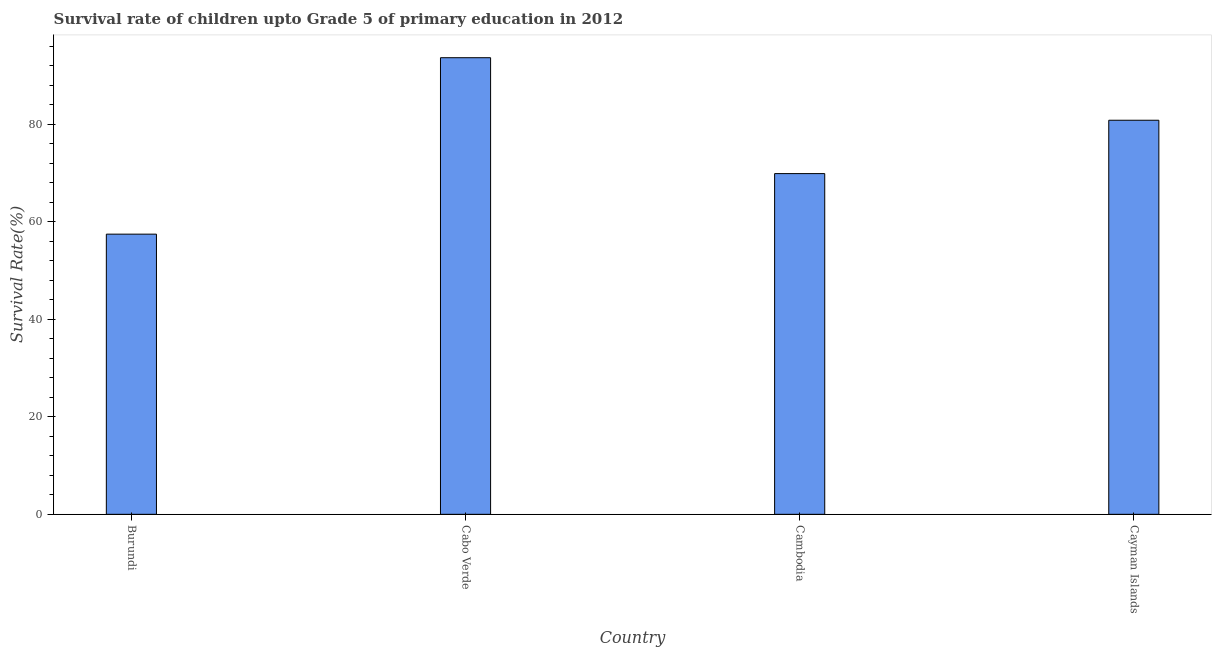Does the graph contain any zero values?
Offer a terse response. No. Does the graph contain grids?
Your response must be concise. No. What is the title of the graph?
Offer a very short reply. Survival rate of children upto Grade 5 of primary education in 2012 . What is the label or title of the X-axis?
Make the answer very short. Country. What is the label or title of the Y-axis?
Offer a terse response. Survival Rate(%). What is the survival rate in Burundi?
Your response must be concise. 57.44. Across all countries, what is the maximum survival rate?
Keep it short and to the point. 93.62. Across all countries, what is the minimum survival rate?
Offer a terse response. 57.44. In which country was the survival rate maximum?
Provide a succinct answer. Cabo Verde. In which country was the survival rate minimum?
Your answer should be very brief. Burundi. What is the sum of the survival rate?
Offer a terse response. 301.72. What is the difference between the survival rate in Burundi and Cabo Verde?
Make the answer very short. -36.17. What is the average survival rate per country?
Your answer should be very brief. 75.43. What is the median survival rate?
Your response must be concise. 75.33. In how many countries, is the survival rate greater than 4 %?
Your answer should be compact. 4. What is the ratio of the survival rate in Cabo Verde to that in Cambodia?
Provide a succinct answer. 1.34. Is the survival rate in Burundi less than that in Cabo Verde?
Give a very brief answer. Yes. What is the difference between the highest and the second highest survival rate?
Offer a terse response. 12.82. Is the sum of the survival rate in Cabo Verde and Cayman Islands greater than the maximum survival rate across all countries?
Your answer should be very brief. Yes. What is the difference between the highest and the lowest survival rate?
Your answer should be very brief. 36.18. How many bars are there?
Provide a succinct answer. 4. How many countries are there in the graph?
Provide a short and direct response. 4. What is the difference between two consecutive major ticks on the Y-axis?
Your answer should be very brief. 20. What is the Survival Rate(%) in Burundi?
Offer a terse response. 57.44. What is the Survival Rate(%) of Cabo Verde?
Your answer should be compact. 93.62. What is the Survival Rate(%) in Cambodia?
Provide a succinct answer. 69.86. What is the Survival Rate(%) in Cayman Islands?
Your answer should be very brief. 80.8. What is the difference between the Survival Rate(%) in Burundi and Cabo Verde?
Provide a short and direct response. -36.18. What is the difference between the Survival Rate(%) in Burundi and Cambodia?
Provide a short and direct response. -12.41. What is the difference between the Survival Rate(%) in Burundi and Cayman Islands?
Provide a succinct answer. -23.35. What is the difference between the Survival Rate(%) in Cabo Verde and Cambodia?
Provide a succinct answer. 23.76. What is the difference between the Survival Rate(%) in Cabo Verde and Cayman Islands?
Give a very brief answer. 12.82. What is the difference between the Survival Rate(%) in Cambodia and Cayman Islands?
Your answer should be compact. -10.94. What is the ratio of the Survival Rate(%) in Burundi to that in Cabo Verde?
Your response must be concise. 0.61. What is the ratio of the Survival Rate(%) in Burundi to that in Cambodia?
Provide a succinct answer. 0.82. What is the ratio of the Survival Rate(%) in Burundi to that in Cayman Islands?
Make the answer very short. 0.71. What is the ratio of the Survival Rate(%) in Cabo Verde to that in Cambodia?
Provide a short and direct response. 1.34. What is the ratio of the Survival Rate(%) in Cabo Verde to that in Cayman Islands?
Offer a very short reply. 1.16. What is the ratio of the Survival Rate(%) in Cambodia to that in Cayman Islands?
Your response must be concise. 0.86. 